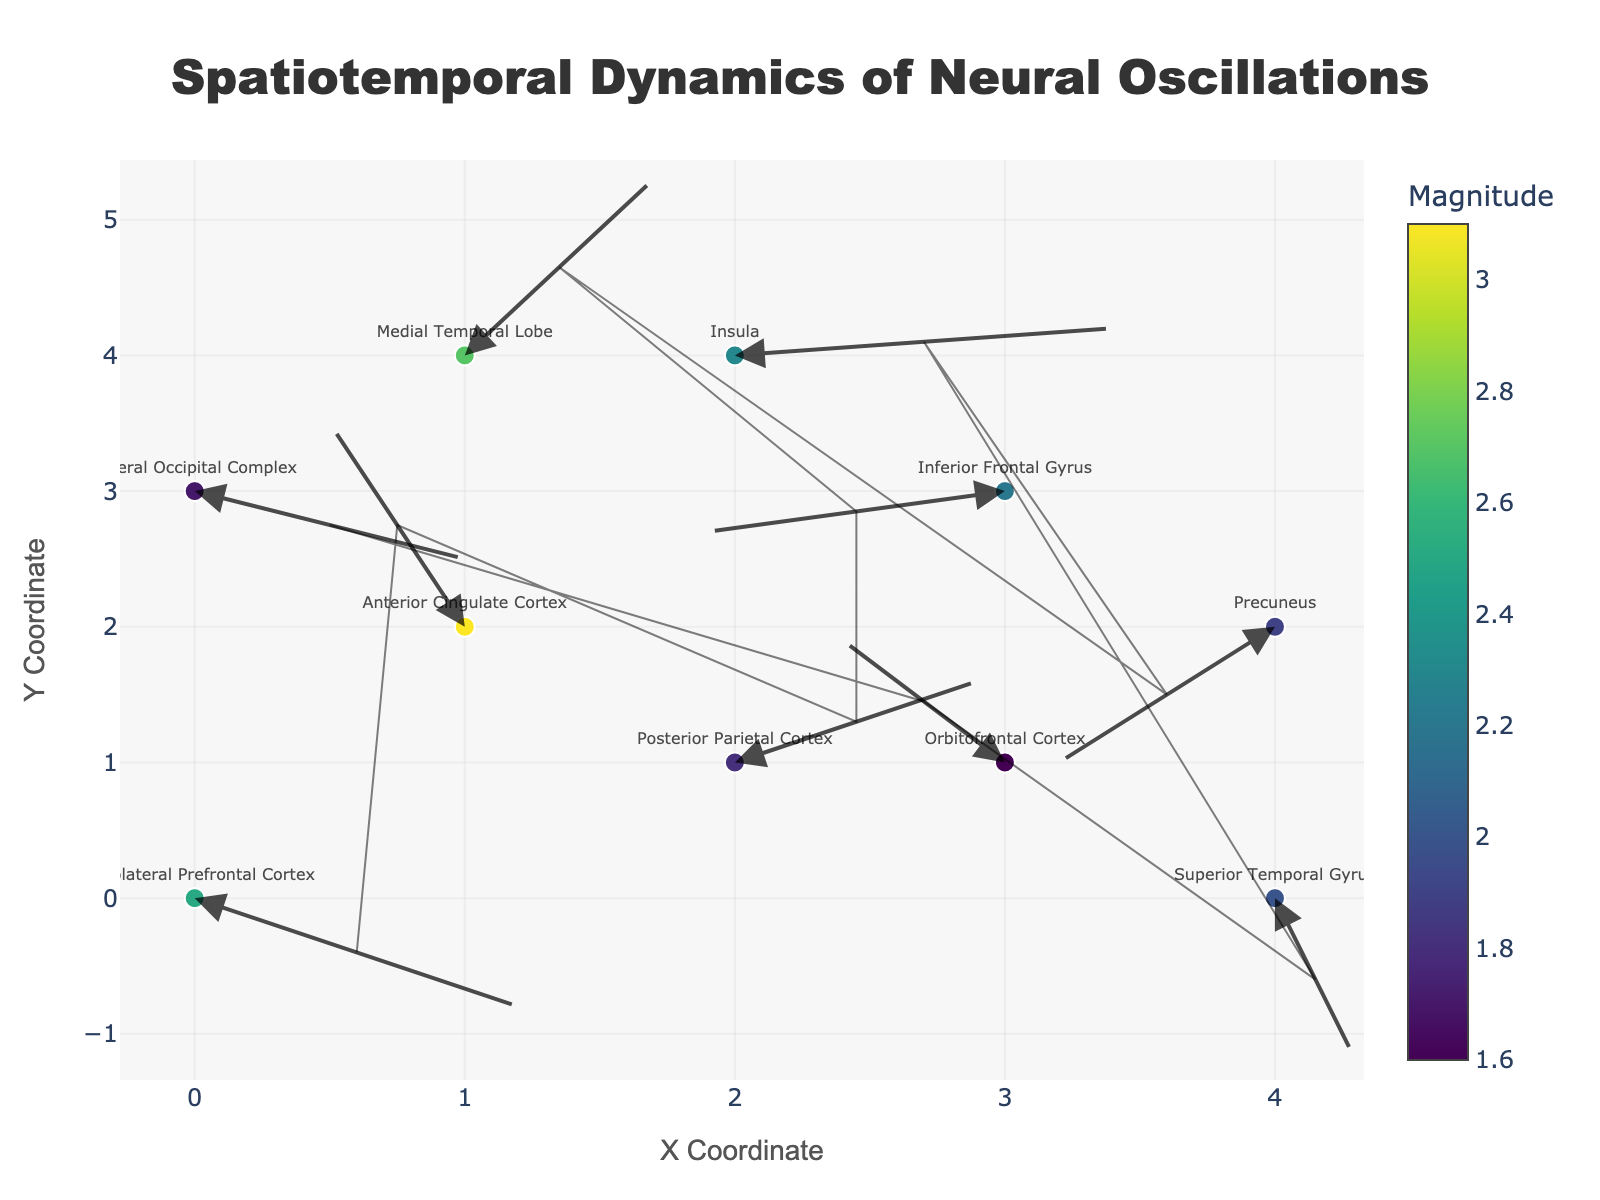What is the range of the magnitude color scale? The color scale for magnitude is shown next to the plot. The minimum magnitude value is associated with the darkest color, and the maximum magnitude value is associated with the brightest color.
Answer: 1.6 to 3.1 Which brain region corresponds to the largest vector? The largest vector is identified by the highest magnitude shown on the color scale. By looking at the hover information or directly correlating the color to the magnitude scale, we can determine the corresponding brain region.
Answer: Anterior Cingulate Cortex What is the direction and magnitude of the vector starting at (3, 1)? Find the data point at coordinates (3, 1) and refer to the hover information for the specific direction and magnitude details.
Answer: Direction: (-0.6, 0.9), Magnitude: 1.6 Which brain region has the vector directed most negatively in the x-axis? Identify the vector with the most negative x-direction component (u). Check the hover information for directional details.
Answer: Inferior Frontal Gyrus (-1.1, -0.3) What are the coordinates and direction of the vector representing the Posterior Parietal Cortex? Locate the Posterior Parietal Cortex data point using the hover text, and note its coordinates and direction from the plot.
Answer: Coordinates: (2, 1), Direction: (0.9, 0.6) How many vectors are there with a positive y-component? Go through the vectors and count how many have a positive value of 'v' which signifies the y-component.
Answer: 5 vectors Which brain region has a vector starting at the origin (0, 0)? Find the vector at the origin’s coordinates and see the hover information for the associated brain region.
Answer: Dorsolateral Prefrontal Cortex What is the total magnitude sum for vectors with a negative x-component? Identify vectors with negative 'u' values, look at their magnitudes from the color and hover details, and sum these magnitudes.
Answer: 2.2 (Inferior Frontal Gyrus) + 1.9 (Precuneus) + (total remaining negative x-component magnitudes) What brain region does the vector at (4, 0) belong to, and what is its magnitude? Check the hover information of the data point at (4, 0) for the brain region and magnitude.
Answer: Superior Temporal Gyrus, Magnitude: 2.0 